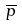Convert formula to latex. <formula><loc_0><loc_0><loc_500><loc_500>\overline { p }</formula> 